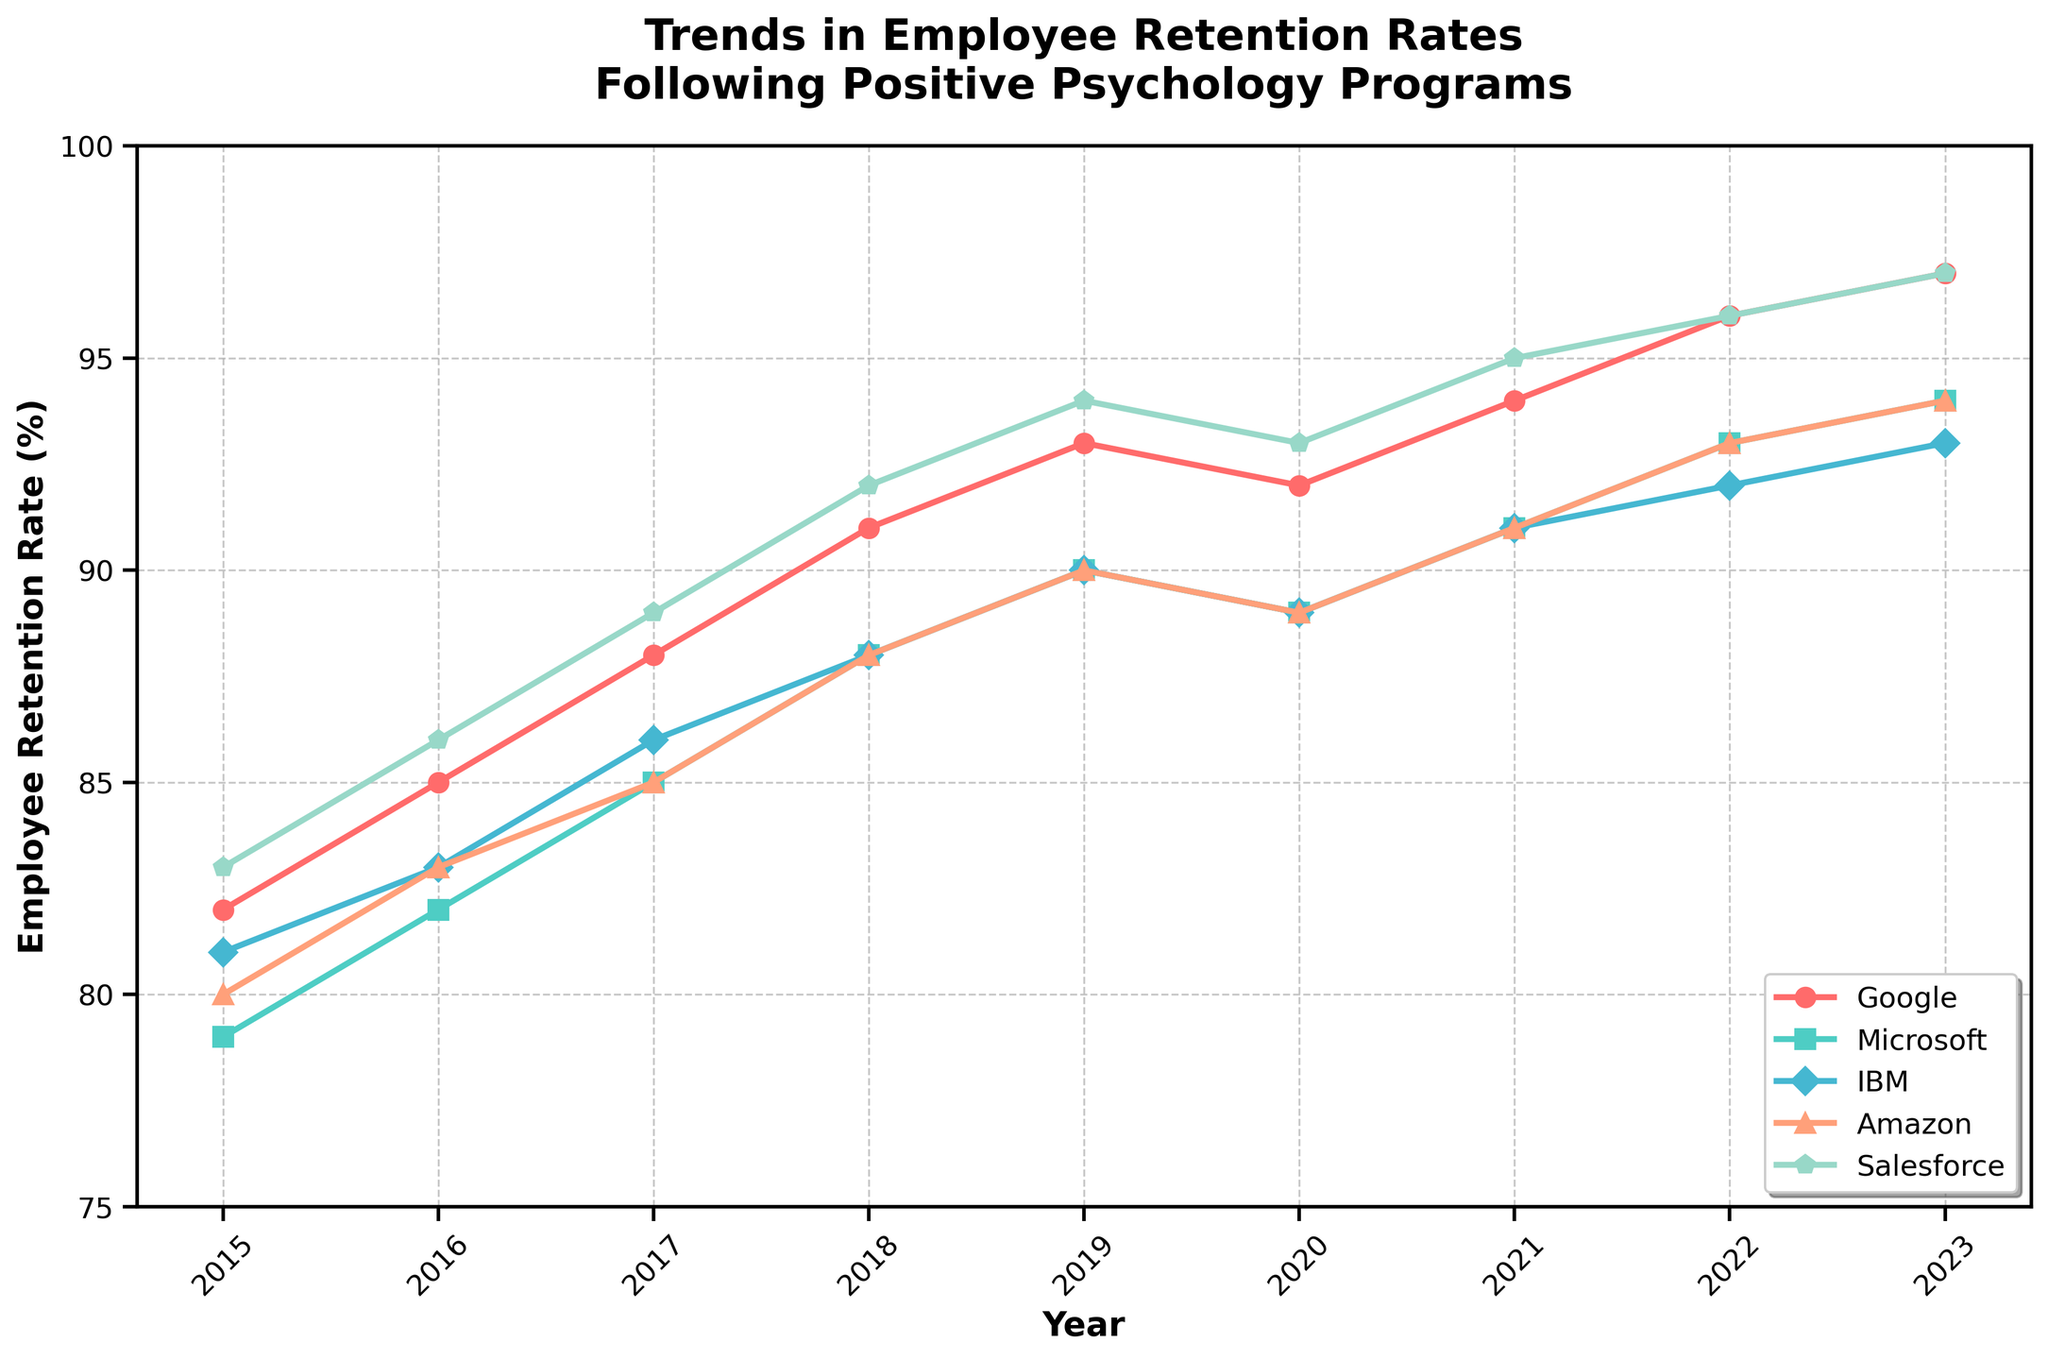What is the trend in the employee retention rate for Google from 2015 to 2023? From the line chart, observe the data points for Google from 2015 to 2023. Note the retention rate increases each year, starting at 82% in 2015 and reaching 97% by 2023.
Answer: The retention rate for Google consistently increased from 82% to 97% Which company had the highest employee retention rate in 2023? Look at the data points for all companies in 2023. Compare the numbers: Google (97), Microsoft (94), IBM (93), Amazon (94), and Salesforce (97). Both Google and Salesforce have the highest, at 97%.
Answer: Google and Salesforce In which year did Microsoft first surpass an employee retention rate of 90%? Identify the points where Microsoft's retention rate surpasses 90%. Check in each year sequentially: it first reaches 91% in 2021.
Answer: 2021 Between 2018 and 2023, which company had the smallest change in employee retention rate? Calculate the difference in retention rates between 2018 and 2023 for each company: Google (97-91=6), Microsoft (94-88=6), IBM (93-88=5), Amazon (94-88=6), and Salesforce (97-92=5). IBM and Salesforce had the smallest changes, both with a 5% increase.
Answer: IBM and Salesforce What was the average retention rate for Amazon over the period from 2015 to 2023? Find the data points for Amazon from 2015 to 2023: 80, 83, 85, 88, 90, 89, 91, 93, 94. Sum these values and divide by 9 (years): (80+83+85+88+90+89+91+93+94)/9 = 793/9 ≈ 88.1.
Answer: Approximately 88.1% Was there any year when Google's retention rate decreased compared to the previous year? Examine the trend line for Google. From 2015 to 2023, the retention rate steadily increases every year except between 2019 and 2020, where it drops from 93% to 92%.
Answer: Yes, in 2020 Compare the trends of Google and IBM: which company had a more consistent retention increase from 2015 to 2023? Look at the rate of change in the line plots for Google and IBM. Google's line shows a steady, consistent rise, while IBM's line has fluctuations, occasionally pausing or decreasing. Thus, Google's trend is more consistent.
Answer: Google From the figure, estimate the employee retention rate for Salesforce in 2018 and verify its accuracy. Visually identify the data point for Salesforce in 2018, which noticeably aligns around 92%. Check the exact data to confirm. The value for Salesforce in 2018 is indeed 92%.
Answer: 92% Among all companies, who had the most significant increase in employee retention rate from 2015 to 2023? Calculate the increase in retention rates from 2015 to 2023 for all companies: Google (97-82=15), Microsoft (94-79=15), IBM (93-81=12), Amazon (94-80=14), and Salesforce (97-83=14). Google and Microsoft have the highest increase, at 15%.
Answer: Google and Microsoft In what year did IBM and Amazon have the same employee retention rate, according to the chart? Look for intersecting points or horizontally aligned data points for IBM and Amazon. In 2018 and 2019, both IBM and Amazon have a retention rate of 88% and 90%, respectively.
Answer: 2018 and 2019 